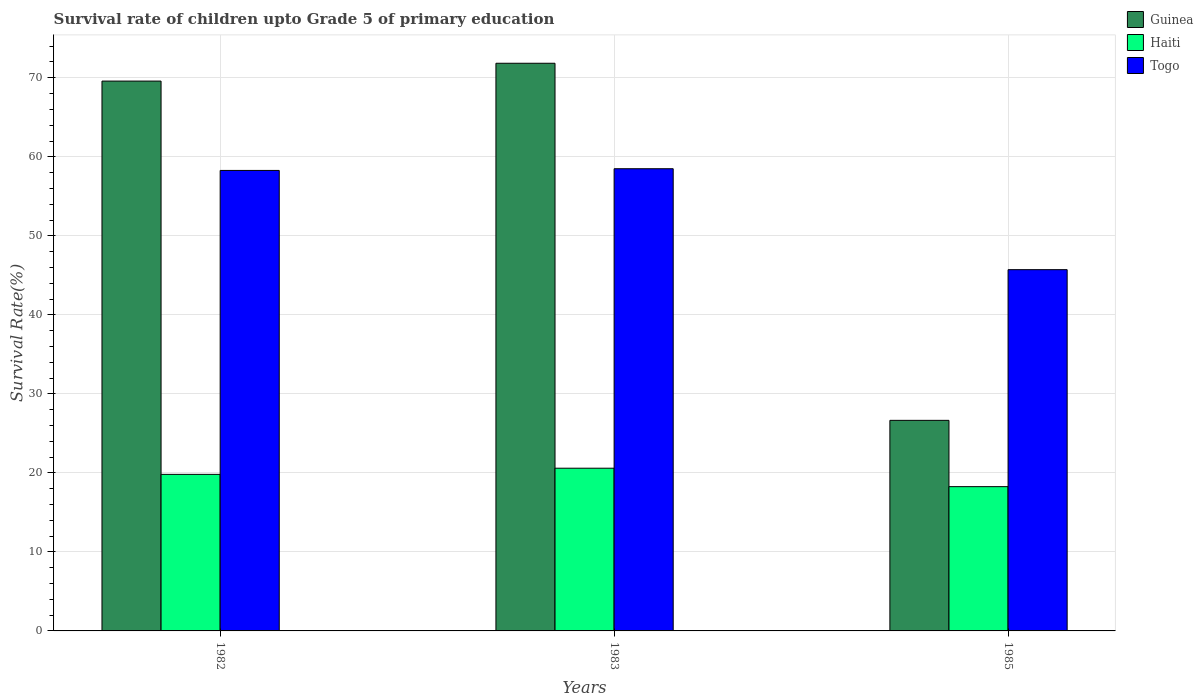How many different coloured bars are there?
Provide a succinct answer. 3. How many groups of bars are there?
Your response must be concise. 3. Are the number of bars per tick equal to the number of legend labels?
Your response must be concise. Yes. Are the number of bars on each tick of the X-axis equal?
Your answer should be very brief. Yes. What is the label of the 2nd group of bars from the left?
Your answer should be very brief. 1983. What is the survival rate of children in Guinea in 1983?
Your response must be concise. 71.84. Across all years, what is the maximum survival rate of children in Guinea?
Offer a terse response. 71.84. Across all years, what is the minimum survival rate of children in Togo?
Your answer should be very brief. 45.72. What is the total survival rate of children in Togo in the graph?
Ensure brevity in your answer.  162.49. What is the difference between the survival rate of children in Haiti in 1983 and that in 1985?
Provide a short and direct response. 2.33. What is the difference between the survival rate of children in Togo in 1982 and the survival rate of children in Guinea in 1985?
Offer a very short reply. 31.63. What is the average survival rate of children in Guinea per year?
Your response must be concise. 56.02. In the year 1982, what is the difference between the survival rate of children in Togo and survival rate of children in Guinea?
Your response must be concise. -11.31. In how many years, is the survival rate of children in Togo greater than 28 %?
Make the answer very short. 3. What is the ratio of the survival rate of children in Haiti in 1982 to that in 1983?
Your answer should be compact. 0.96. Is the survival rate of children in Haiti in 1983 less than that in 1985?
Provide a short and direct response. No. What is the difference between the highest and the second highest survival rate of children in Haiti?
Give a very brief answer. 0.78. What is the difference between the highest and the lowest survival rate of children in Guinea?
Give a very brief answer. 45.19. What does the 2nd bar from the left in 1983 represents?
Give a very brief answer. Haiti. What does the 3rd bar from the right in 1985 represents?
Ensure brevity in your answer.  Guinea. How many bars are there?
Offer a very short reply. 9. How many years are there in the graph?
Ensure brevity in your answer.  3. Are the values on the major ticks of Y-axis written in scientific E-notation?
Your response must be concise. No. Does the graph contain any zero values?
Your response must be concise. No. Does the graph contain grids?
Your answer should be compact. Yes. Where does the legend appear in the graph?
Give a very brief answer. Top right. How are the legend labels stacked?
Your answer should be compact. Vertical. What is the title of the graph?
Provide a succinct answer. Survival rate of children upto Grade 5 of primary education. What is the label or title of the Y-axis?
Your response must be concise. Survival Rate(%). What is the Survival Rate(%) of Guinea in 1982?
Your answer should be very brief. 69.59. What is the Survival Rate(%) in Haiti in 1982?
Offer a very short reply. 19.81. What is the Survival Rate(%) in Togo in 1982?
Your response must be concise. 58.28. What is the Survival Rate(%) of Guinea in 1983?
Your answer should be very brief. 71.84. What is the Survival Rate(%) of Haiti in 1983?
Offer a very short reply. 20.59. What is the Survival Rate(%) of Togo in 1983?
Your response must be concise. 58.49. What is the Survival Rate(%) of Guinea in 1985?
Provide a succinct answer. 26.65. What is the Survival Rate(%) of Haiti in 1985?
Your answer should be very brief. 18.26. What is the Survival Rate(%) of Togo in 1985?
Offer a very short reply. 45.72. Across all years, what is the maximum Survival Rate(%) of Guinea?
Your answer should be compact. 71.84. Across all years, what is the maximum Survival Rate(%) in Haiti?
Offer a very short reply. 20.59. Across all years, what is the maximum Survival Rate(%) in Togo?
Make the answer very short. 58.49. Across all years, what is the minimum Survival Rate(%) in Guinea?
Your response must be concise. 26.65. Across all years, what is the minimum Survival Rate(%) of Haiti?
Your answer should be compact. 18.26. Across all years, what is the minimum Survival Rate(%) in Togo?
Ensure brevity in your answer.  45.72. What is the total Survival Rate(%) of Guinea in the graph?
Your answer should be compact. 168.07. What is the total Survival Rate(%) of Haiti in the graph?
Make the answer very short. 58.66. What is the total Survival Rate(%) of Togo in the graph?
Give a very brief answer. 162.49. What is the difference between the Survival Rate(%) of Guinea in 1982 and that in 1983?
Your answer should be very brief. -2.26. What is the difference between the Survival Rate(%) in Haiti in 1982 and that in 1983?
Ensure brevity in your answer.  -0.78. What is the difference between the Survival Rate(%) in Togo in 1982 and that in 1983?
Give a very brief answer. -0.21. What is the difference between the Survival Rate(%) in Guinea in 1982 and that in 1985?
Provide a succinct answer. 42.94. What is the difference between the Survival Rate(%) in Haiti in 1982 and that in 1985?
Make the answer very short. 1.55. What is the difference between the Survival Rate(%) in Togo in 1982 and that in 1985?
Give a very brief answer. 12.56. What is the difference between the Survival Rate(%) of Guinea in 1983 and that in 1985?
Your answer should be very brief. 45.19. What is the difference between the Survival Rate(%) of Haiti in 1983 and that in 1985?
Provide a short and direct response. 2.33. What is the difference between the Survival Rate(%) of Togo in 1983 and that in 1985?
Offer a very short reply. 12.77. What is the difference between the Survival Rate(%) of Guinea in 1982 and the Survival Rate(%) of Haiti in 1983?
Offer a very short reply. 48.99. What is the difference between the Survival Rate(%) in Guinea in 1982 and the Survival Rate(%) in Togo in 1983?
Offer a terse response. 11.09. What is the difference between the Survival Rate(%) in Haiti in 1982 and the Survival Rate(%) in Togo in 1983?
Offer a very short reply. -38.68. What is the difference between the Survival Rate(%) in Guinea in 1982 and the Survival Rate(%) in Haiti in 1985?
Make the answer very short. 51.33. What is the difference between the Survival Rate(%) of Guinea in 1982 and the Survival Rate(%) of Togo in 1985?
Your response must be concise. 23.87. What is the difference between the Survival Rate(%) of Haiti in 1982 and the Survival Rate(%) of Togo in 1985?
Give a very brief answer. -25.91. What is the difference between the Survival Rate(%) of Guinea in 1983 and the Survival Rate(%) of Haiti in 1985?
Provide a succinct answer. 53.58. What is the difference between the Survival Rate(%) of Guinea in 1983 and the Survival Rate(%) of Togo in 1985?
Provide a succinct answer. 26.12. What is the difference between the Survival Rate(%) of Haiti in 1983 and the Survival Rate(%) of Togo in 1985?
Provide a succinct answer. -25.13. What is the average Survival Rate(%) of Guinea per year?
Ensure brevity in your answer.  56.02. What is the average Survival Rate(%) in Haiti per year?
Your answer should be very brief. 19.55. What is the average Survival Rate(%) in Togo per year?
Make the answer very short. 54.16. In the year 1982, what is the difference between the Survival Rate(%) of Guinea and Survival Rate(%) of Haiti?
Your answer should be compact. 49.77. In the year 1982, what is the difference between the Survival Rate(%) of Guinea and Survival Rate(%) of Togo?
Ensure brevity in your answer.  11.31. In the year 1982, what is the difference between the Survival Rate(%) of Haiti and Survival Rate(%) of Togo?
Your response must be concise. -38.47. In the year 1983, what is the difference between the Survival Rate(%) in Guinea and Survival Rate(%) in Haiti?
Keep it short and to the point. 51.25. In the year 1983, what is the difference between the Survival Rate(%) in Guinea and Survival Rate(%) in Togo?
Your answer should be compact. 13.35. In the year 1983, what is the difference between the Survival Rate(%) in Haiti and Survival Rate(%) in Togo?
Your answer should be very brief. -37.9. In the year 1985, what is the difference between the Survival Rate(%) of Guinea and Survival Rate(%) of Haiti?
Your answer should be very brief. 8.39. In the year 1985, what is the difference between the Survival Rate(%) of Guinea and Survival Rate(%) of Togo?
Provide a succinct answer. -19.07. In the year 1985, what is the difference between the Survival Rate(%) of Haiti and Survival Rate(%) of Togo?
Ensure brevity in your answer.  -27.46. What is the ratio of the Survival Rate(%) of Guinea in 1982 to that in 1983?
Provide a short and direct response. 0.97. What is the ratio of the Survival Rate(%) in Haiti in 1982 to that in 1983?
Provide a succinct answer. 0.96. What is the ratio of the Survival Rate(%) in Togo in 1982 to that in 1983?
Give a very brief answer. 1. What is the ratio of the Survival Rate(%) of Guinea in 1982 to that in 1985?
Your answer should be very brief. 2.61. What is the ratio of the Survival Rate(%) of Haiti in 1982 to that in 1985?
Offer a terse response. 1.09. What is the ratio of the Survival Rate(%) in Togo in 1982 to that in 1985?
Provide a short and direct response. 1.27. What is the ratio of the Survival Rate(%) of Guinea in 1983 to that in 1985?
Ensure brevity in your answer.  2.7. What is the ratio of the Survival Rate(%) of Haiti in 1983 to that in 1985?
Provide a succinct answer. 1.13. What is the ratio of the Survival Rate(%) in Togo in 1983 to that in 1985?
Provide a short and direct response. 1.28. What is the difference between the highest and the second highest Survival Rate(%) in Guinea?
Your answer should be compact. 2.26. What is the difference between the highest and the second highest Survival Rate(%) in Haiti?
Ensure brevity in your answer.  0.78. What is the difference between the highest and the second highest Survival Rate(%) in Togo?
Give a very brief answer. 0.21. What is the difference between the highest and the lowest Survival Rate(%) of Guinea?
Your response must be concise. 45.19. What is the difference between the highest and the lowest Survival Rate(%) in Haiti?
Keep it short and to the point. 2.33. What is the difference between the highest and the lowest Survival Rate(%) in Togo?
Your answer should be compact. 12.77. 